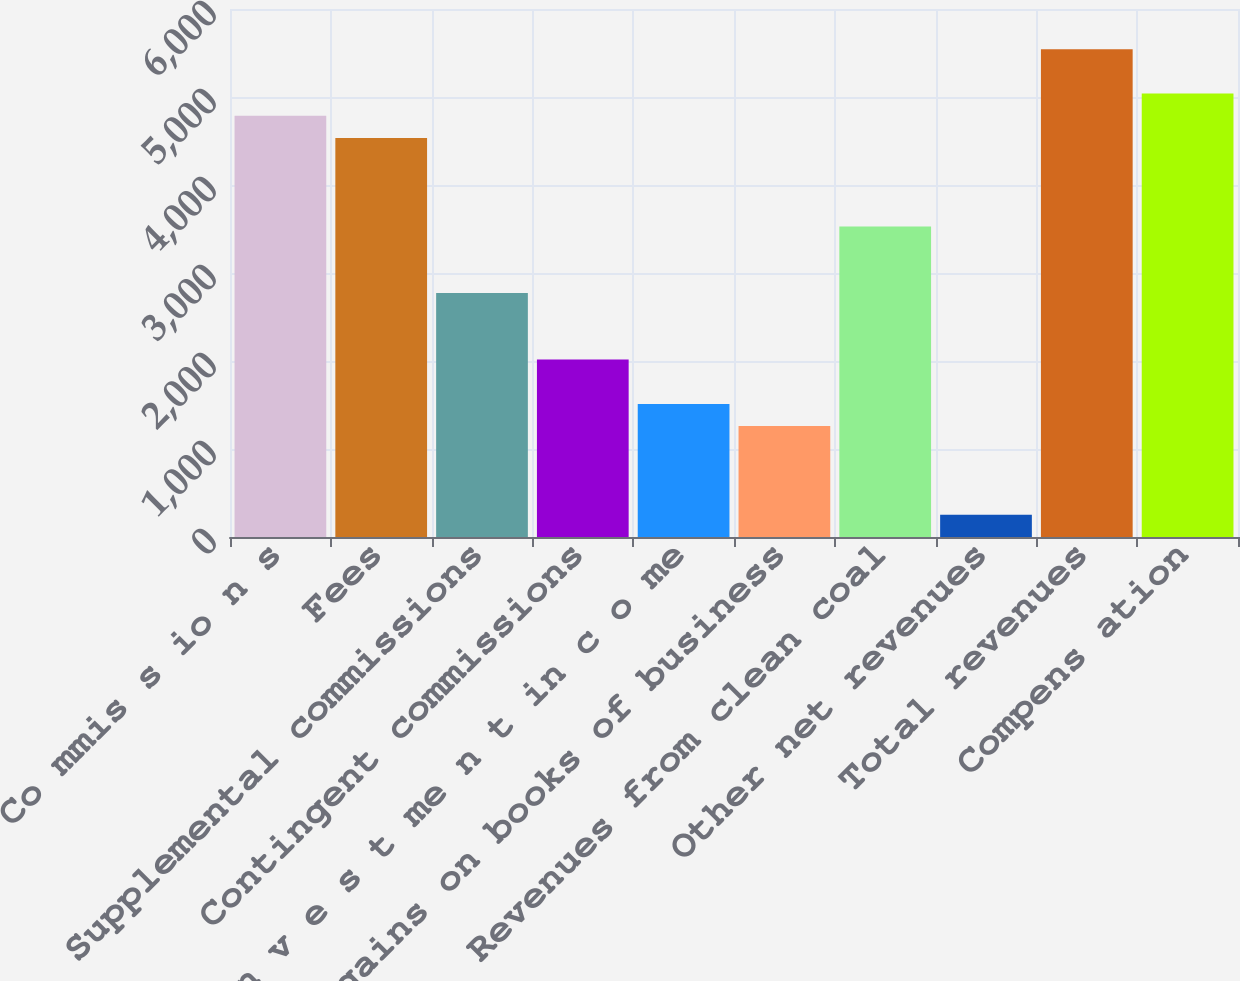Convert chart. <chart><loc_0><loc_0><loc_500><loc_500><bar_chart><fcel>Co mmis s io n s<fcel>Fees<fcel>Supplemental commissions<fcel>Contingent commissions<fcel>In v e s t me n t in c o me<fcel>Net gains on books of business<fcel>Revenues from clean coal<fcel>Other net revenues<fcel>Total revenues<fcel>Compens ation<nl><fcel>4787.27<fcel>4535.38<fcel>2772.15<fcel>2016.48<fcel>1512.7<fcel>1260.81<fcel>3527.82<fcel>253.25<fcel>5542.94<fcel>5039.16<nl></chart> 